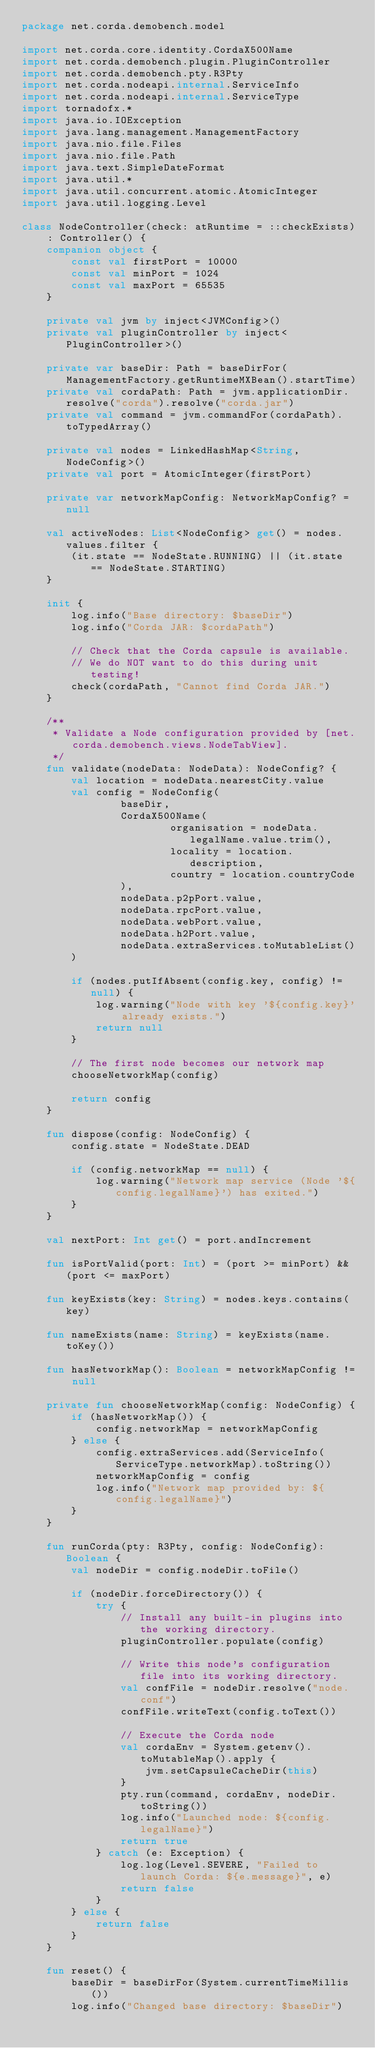Convert code to text. <code><loc_0><loc_0><loc_500><loc_500><_Kotlin_>package net.corda.demobench.model

import net.corda.core.identity.CordaX500Name
import net.corda.demobench.plugin.PluginController
import net.corda.demobench.pty.R3Pty
import net.corda.nodeapi.internal.ServiceInfo
import net.corda.nodeapi.internal.ServiceType
import tornadofx.*
import java.io.IOException
import java.lang.management.ManagementFactory
import java.nio.file.Files
import java.nio.file.Path
import java.text.SimpleDateFormat
import java.util.*
import java.util.concurrent.atomic.AtomicInteger
import java.util.logging.Level

class NodeController(check: atRuntime = ::checkExists) : Controller() {
    companion object {
        const val firstPort = 10000
        const val minPort = 1024
        const val maxPort = 65535
    }

    private val jvm by inject<JVMConfig>()
    private val pluginController by inject<PluginController>()

    private var baseDir: Path = baseDirFor(ManagementFactory.getRuntimeMXBean().startTime)
    private val cordaPath: Path = jvm.applicationDir.resolve("corda").resolve("corda.jar")
    private val command = jvm.commandFor(cordaPath).toTypedArray()

    private val nodes = LinkedHashMap<String, NodeConfig>()
    private val port = AtomicInteger(firstPort)

    private var networkMapConfig: NetworkMapConfig? = null

    val activeNodes: List<NodeConfig> get() = nodes.values.filter {
        (it.state == NodeState.RUNNING) || (it.state == NodeState.STARTING)
    }

    init {
        log.info("Base directory: $baseDir")
        log.info("Corda JAR: $cordaPath")

        // Check that the Corda capsule is available.
        // We do NOT want to do this during unit testing!
        check(cordaPath, "Cannot find Corda JAR.")
    }

    /**
     * Validate a Node configuration provided by [net.corda.demobench.views.NodeTabView].
     */
    fun validate(nodeData: NodeData): NodeConfig? {
        val location = nodeData.nearestCity.value
        val config = NodeConfig(
                baseDir,
                CordaX500Name(
                        organisation = nodeData.legalName.value.trim(),
                        locality = location.description,
                        country = location.countryCode
                ),
                nodeData.p2pPort.value,
                nodeData.rpcPort.value,
                nodeData.webPort.value,
                nodeData.h2Port.value,
                nodeData.extraServices.toMutableList()
        )

        if (nodes.putIfAbsent(config.key, config) != null) {
            log.warning("Node with key '${config.key}' already exists.")
            return null
        }

        // The first node becomes our network map
        chooseNetworkMap(config)

        return config
    }

    fun dispose(config: NodeConfig) {
        config.state = NodeState.DEAD

        if (config.networkMap == null) {
            log.warning("Network map service (Node '${config.legalName}') has exited.")
        }
    }

    val nextPort: Int get() = port.andIncrement

    fun isPortValid(port: Int) = (port >= minPort) && (port <= maxPort)

    fun keyExists(key: String) = nodes.keys.contains(key)

    fun nameExists(name: String) = keyExists(name.toKey())

    fun hasNetworkMap(): Boolean = networkMapConfig != null

    private fun chooseNetworkMap(config: NodeConfig) {
        if (hasNetworkMap()) {
            config.networkMap = networkMapConfig
        } else {
            config.extraServices.add(ServiceInfo(ServiceType.networkMap).toString())
            networkMapConfig = config
            log.info("Network map provided by: ${config.legalName}")
        }
    }

    fun runCorda(pty: R3Pty, config: NodeConfig): Boolean {
        val nodeDir = config.nodeDir.toFile()

        if (nodeDir.forceDirectory()) {
            try {
                // Install any built-in plugins into the working directory.
                pluginController.populate(config)

                // Write this node's configuration file into its working directory.
                val confFile = nodeDir.resolve("node.conf")
                confFile.writeText(config.toText())

                // Execute the Corda node
                val cordaEnv = System.getenv().toMutableMap().apply {
                    jvm.setCapsuleCacheDir(this)
                }
                pty.run(command, cordaEnv, nodeDir.toString())
                log.info("Launched node: ${config.legalName}")
                return true
            } catch (e: Exception) {
                log.log(Level.SEVERE, "Failed to launch Corda: ${e.message}", e)
                return false
            }
        } else {
            return false
        }
    }

    fun reset() {
        baseDir = baseDirFor(System.currentTimeMillis())
        log.info("Changed base directory: $baseDir")
</code> 